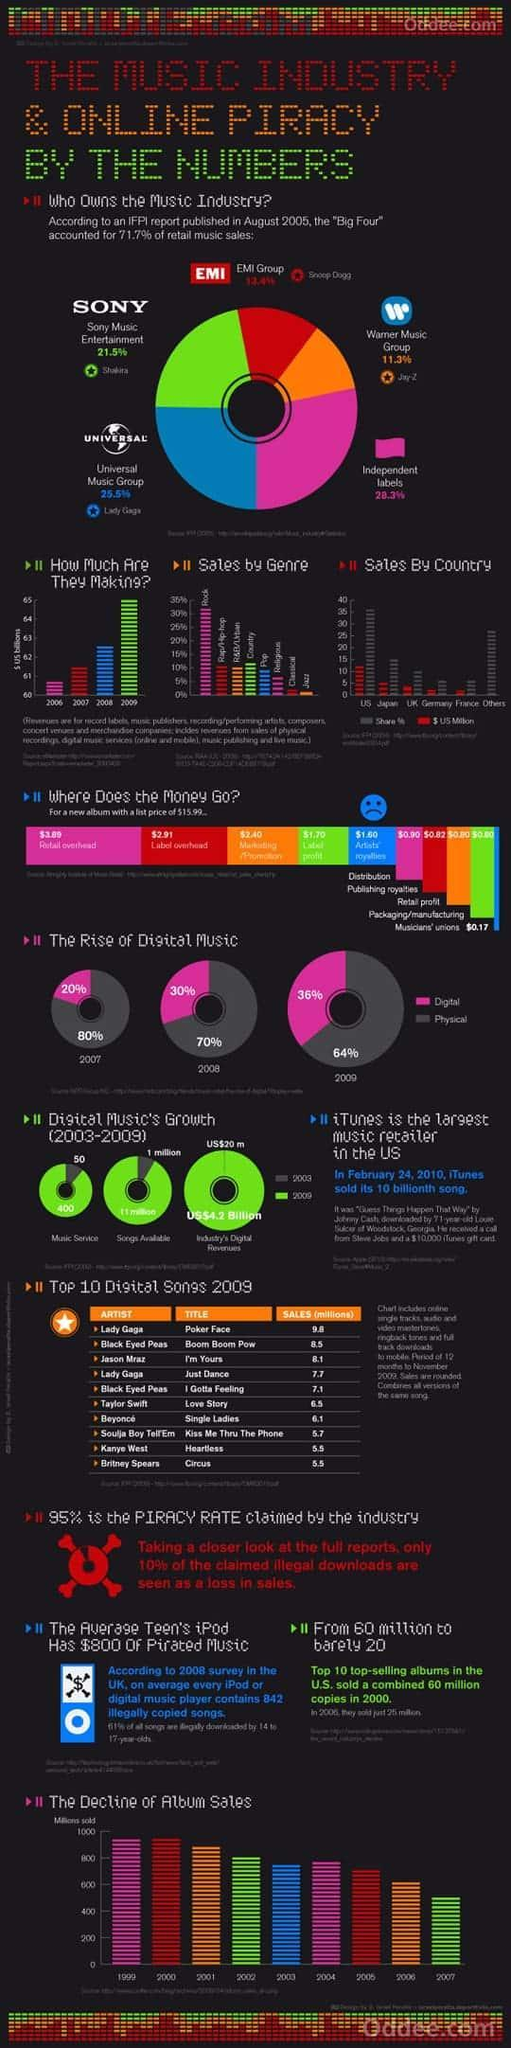In 2009, what was the percentage use of digital music?
Answer the question with a short phrase. 36% What was the percentage of digital music use in 2008? 30% Among the "Big Four" of the music industry which group makes major sales? Universal Music Group Which group accounted for 11.3% of retail music sales? Warner Music Group From the $15.99 price of an album, how much goes into publishing royalties? $0.82 Which song was 4th in the top selling songs of 2009? Just Dance What was the increase in percentage of use of digital music from 2007 to 2008? 10 Among the "Big Four" of the music industry which group makes second highest sales? Sony Music Which was the title of the second top selling song in 2009? Boom Boom Pow What percent of retail music sales is by independent labels? 28.3% 